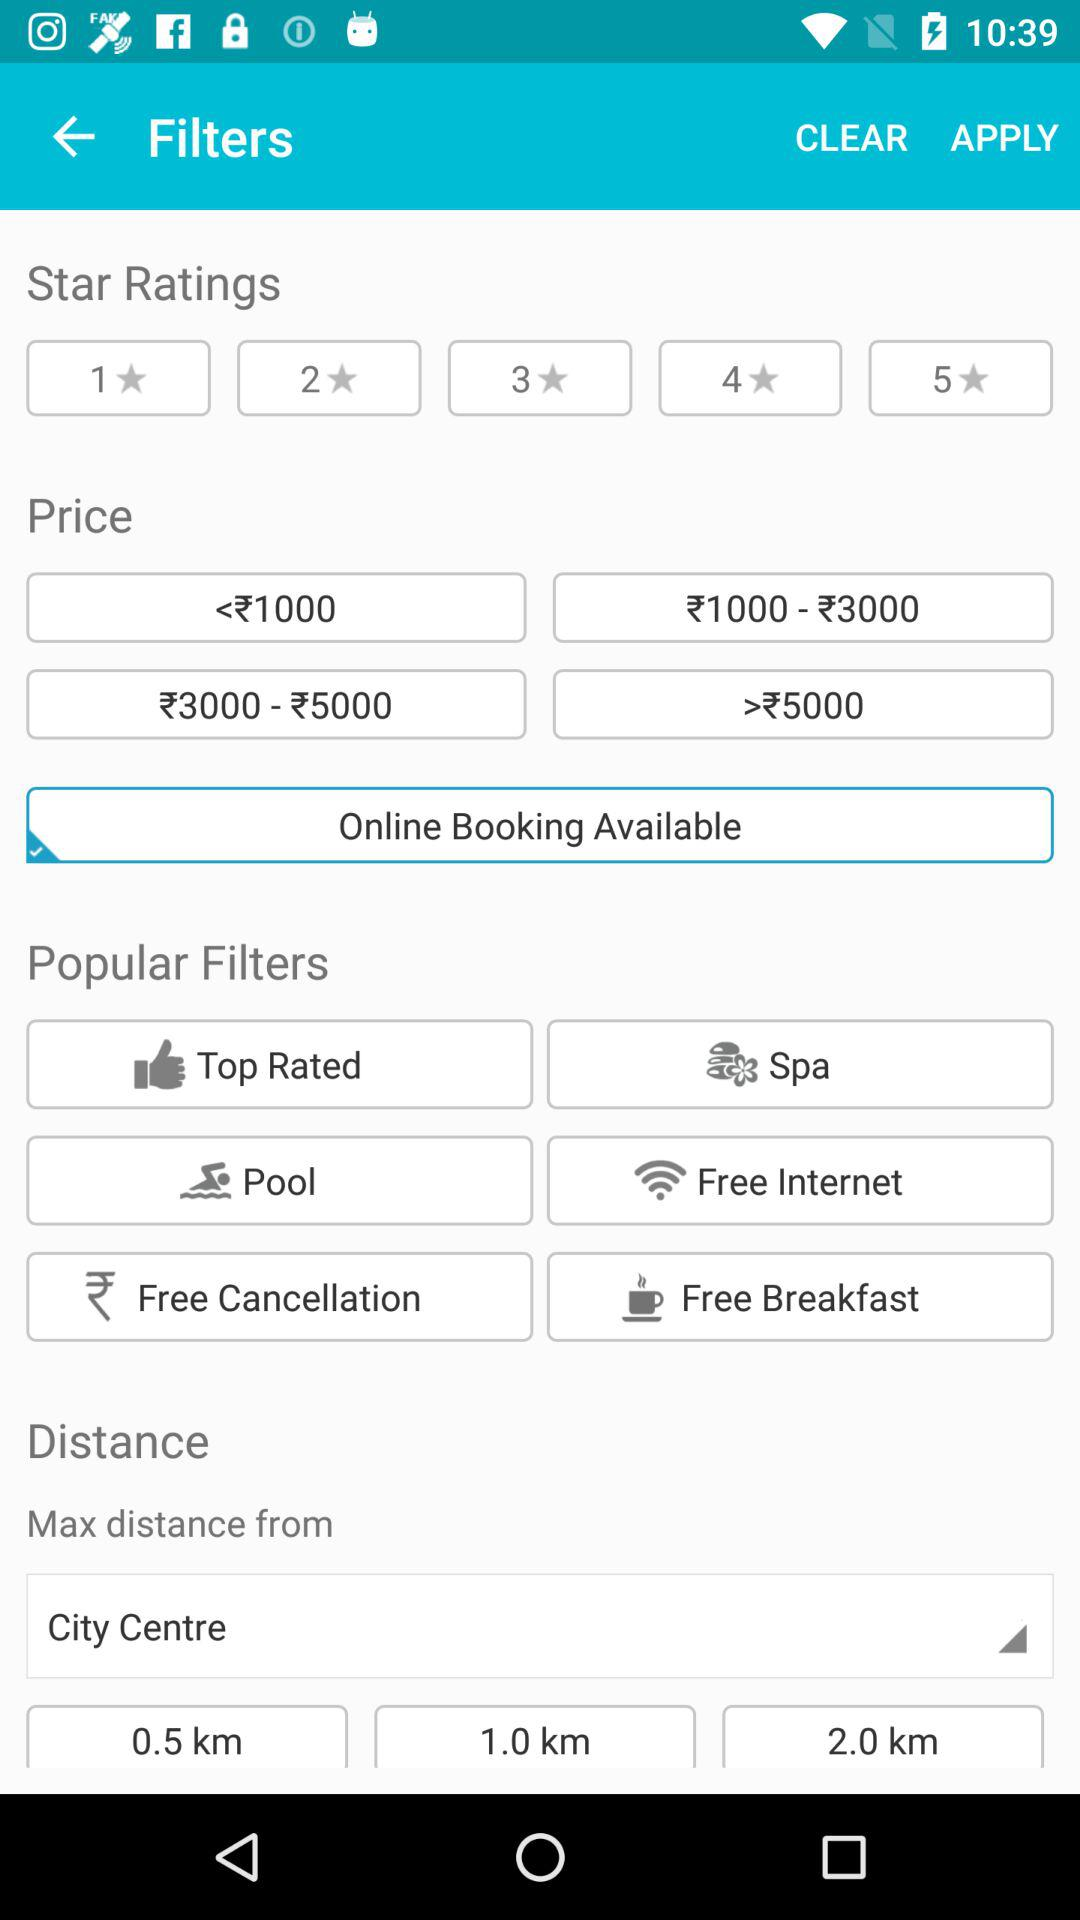How many price ranges are available?
Answer the question using a single word or phrase. 4 